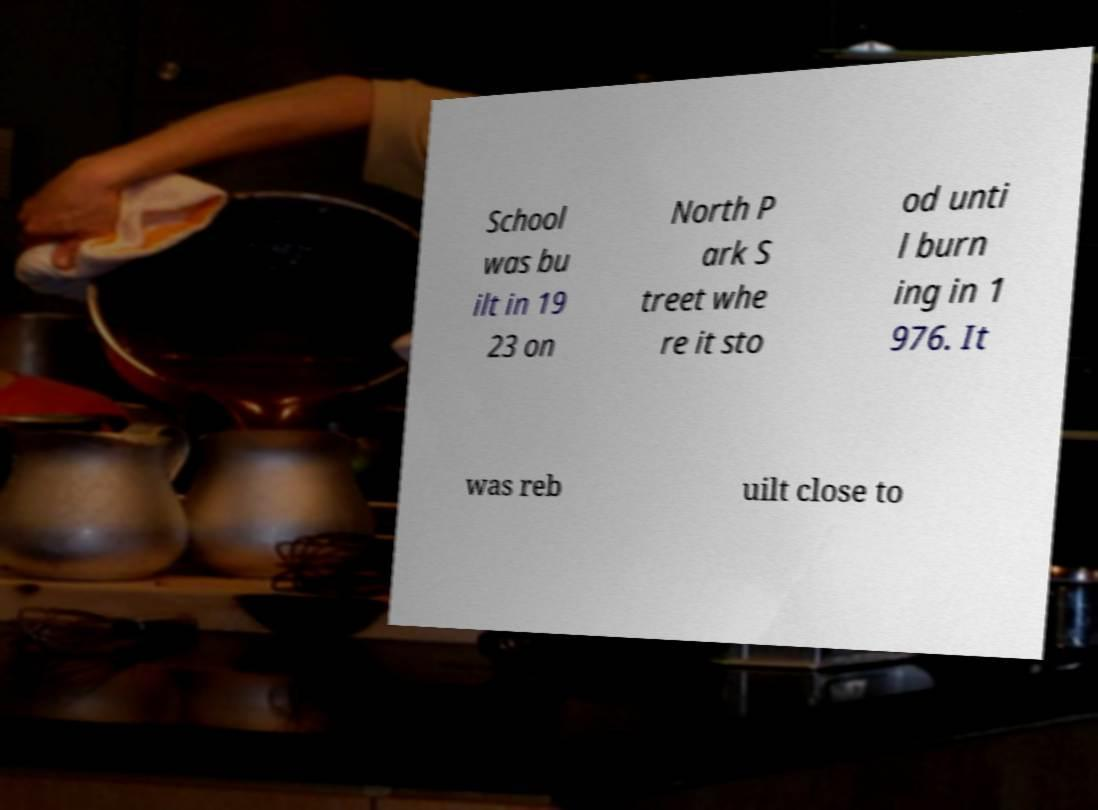I need the written content from this picture converted into text. Can you do that? School was bu ilt in 19 23 on North P ark S treet whe re it sto od unti l burn ing in 1 976. It was reb uilt close to 